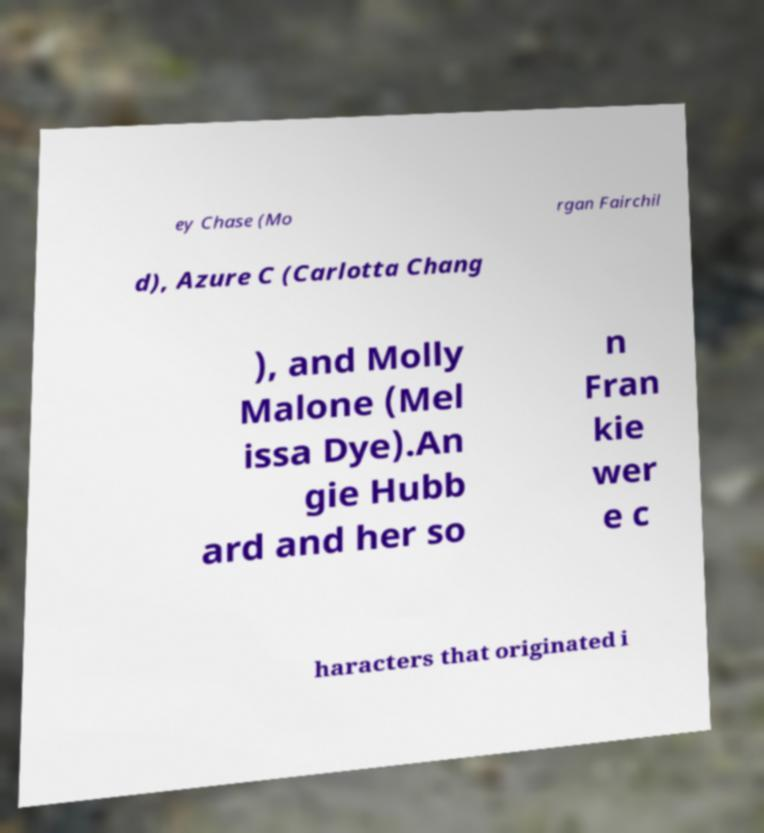Could you extract and type out the text from this image? ey Chase (Mo rgan Fairchil d), Azure C (Carlotta Chang ), and Molly Malone (Mel issa Dye).An gie Hubb ard and her so n Fran kie wer e c haracters that originated i 